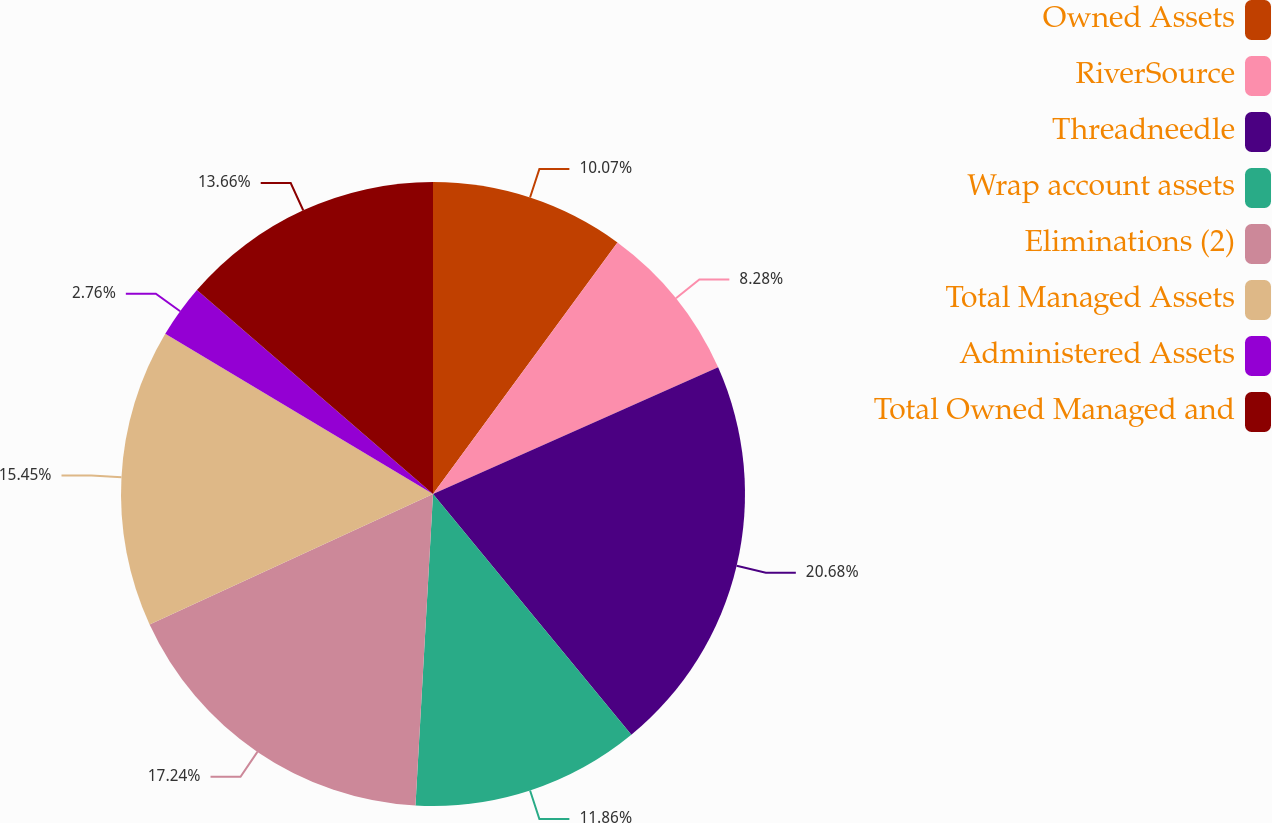Convert chart. <chart><loc_0><loc_0><loc_500><loc_500><pie_chart><fcel>Owned Assets<fcel>RiverSource<fcel>Threadneedle<fcel>Wrap account assets<fcel>Eliminations (2)<fcel>Total Managed Assets<fcel>Administered Assets<fcel>Total Owned Managed and<nl><fcel>10.07%<fcel>8.28%<fcel>20.69%<fcel>11.86%<fcel>17.24%<fcel>15.45%<fcel>2.76%<fcel>13.66%<nl></chart> 